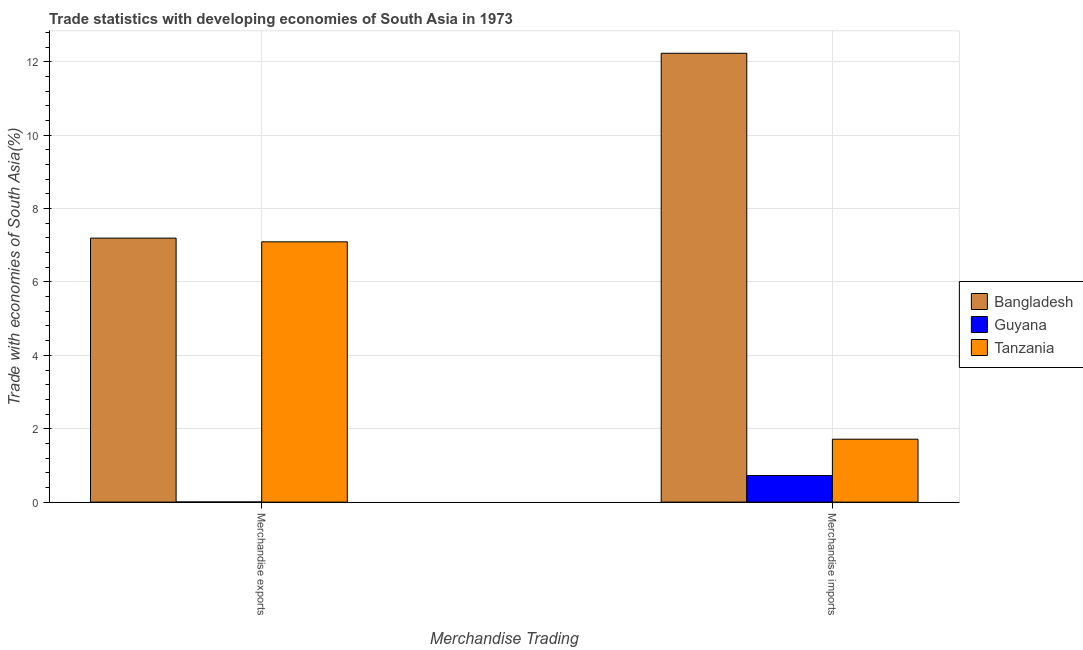How many different coloured bars are there?
Provide a short and direct response. 3. Are the number of bars on each tick of the X-axis equal?
Your answer should be compact. Yes. How many bars are there on the 2nd tick from the left?
Your response must be concise. 3. How many bars are there on the 1st tick from the right?
Your response must be concise. 3. What is the label of the 1st group of bars from the left?
Your response must be concise. Merchandise exports. What is the merchandise exports in Bangladesh?
Provide a succinct answer. 7.19. Across all countries, what is the maximum merchandise imports?
Keep it short and to the point. 12.23. Across all countries, what is the minimum merchandise imports?
Provide a short and direct response. 0.72. In which country was the merchandise imports maximum?
Provide a succinct answer. Bangladesh. In which country was the merchandise imports minimum?
Keep it short and to the point. Guyana. What is the total merchandise imports in the graph?
Provide a short and direct response. 14.67. What is the difference between the merchandise exports in Guyana and that in Tanzania?
Your answer should be compact. -7.09. What is the difference between the merchandise exports in Bangladesh and the merchandise imports in Guyana?
Provide a short and direct response. 6.47. What is the average merchandise exports per country?
Provide a short and direct response. 4.76. What is the difference between the merchandise exports and merchandise imports in Bangladesh?
Your answer should be compact. -5.04. In how many countries, is the merchandise imports greater than 4.8 %?
Give a very brief answer. 1. What is the ratio of the merchandise exports in Tanzania to that in Guyana?
Give a very brief answer. 1628.43. What does the 2nd bar from the left in Merchandise imports represents?
Keep it short and to the point. Guyana. What does the 1st bar from the right in Merchandise exports represents?
Make the answer very short. Tanzania. How many bars are there?
Provide a succinct answer. 6. Are all the bars in the graph horizontal?
Give a very brief answer. No. Are the values on the major ticks of Y-axis written in scientific E-notation?
Offer a terse response. No. Where does the legend appear in the graph?
Provide a succinct answer. Center right. What is the title of the graph?
Provide a short and direct response. Trade statistics with developing economies of South Asia in 1973. Does "Moldova" appear as one of the legend labels in the graph?
Ensure brevity in your answer.  No. What is the label or title of the X-axis?
Keep it short and to the point. Merchandise Trading. What is the label or title of the Y-axis?
Provide a short and direct response. Trade with economies of South Asia(%). What is the Trade with economies of South Asia(%) in Bangladesh in Merchandise exports?
Make the answer very short. 7.19. What is the Trade with economies of South Asia(%) of Guyana in Merchandise exports?
Ensure brevity in your answer.  0. What is the Trade with economies of South Asia(%) of Tanzania in Merchandise exports?
Your answer should be compact. 7.09. What is the Trade with economies of South Asia(%) of Bangladesh in Merchandise imports?
Your answer should be very brief. 12.23. What is the Trade with economies of South Asia(%) in Guyana in Merchandise imports?
Your response must be concise. 0.72. What is the Trade with economies of South Asia(%) in Tanzania in Merchandise imports?
Your response must be concise. 1.72. Across all Merchandise Trading, what is the maximum Trade with economies of South Asia(%) in Bangladesh?
Provide a succinct answer. 12.23. Across all Merchandise Trading, what is the maximum Trade with economies of South Asia(%) in Guyana?
Your answer should be compact. 0.72. Across all Merchandise Trading, what is the maximum Trade with economies of South Asia(%) of Tanzania?
Offer a terse response. 7.09. Across all Merchandise Trading, what is the minimum Trade with economies of South Asia(%) of Bangladesh?
Offer a terse response. 7.19. Across all Merchandise Trading, what is the minimum Trade with economies of South Asia(%) of Guyana?
Make the answer very short. 0. Across all Merchandise Trading, what is the minimum Trade with economies of South Asia(%) in Tanzania?
Your answer should be very brief. 1.72. What is the total Trade with economies of South Asia(%) in Bangladesh in the graph?
Offer a terse response. 19.43. What is the total Trade with economies of South Asia(%) of Guyana in the graph?
Offer a terse response. 0.73. What is the total Trade with economies of South Asia(%) of Tanzania in the graph?
Provide a short and direct response. 8.81. What is the difference between the Trade with economies of South Asia(%) in Bangladesh in Merchandise exports and that in Merchandise imports?
Make the answer very short. -5.04. What is the difference between the Trade with economies of South Asia(%) in Guyana in Merchandise exports and that in Merchandise imports?
Your response must be concise. -0.72. What is the difference between the Trade with economies of South Asia(%) in Tanzania in Merchandise exports and that in Merchandise imports?
Provide a short and direct response. 5.38. What is the difference between the Trade with economies of South Asia(%) of Bangladesh in Merchandise exports and the Trade with economies of South Asia(%) of Guyana in Merchandise imports?
Keep it short and to the point. 6.47. What is the difference between the Trade with economies of South Asia(%) in Bangladesh in Merchandise exports and the Trade with economies of South Asia(%) in Tanzania in Merchandise imports?
Your answer should be very brief. 5.48. What is the difference between the Trade with economies of South Asia(%) of Guyana in Merchandise exports and the Trade with economies of South Asia(%) of Tanzania in Merchandise imports?
Provide a succinct answer. -1.71. What is the average Trade with economies of South Asia(%) of Bangladesh per Merchandise Trading?
Offer a very short reply. 9.71. What is the average Trade with economies of South Asia(%) of Guyana per Merchandise Trading?
Your answer should be compact. 0.36. What is the average Trade with economies of South Asia(%) in Tanzania per Merchandise Trading?
Offer a very short reply. 4.4. What is the difference between the Trade with economies of South Asia(%) of Bangladesh and Trade with economies of South Asia(%) of Guyana in Merchandise exports?
Ensure brevity in your answer.  7.19. What is the difference between the Trade with economies of South Asia(%) of Bangladesh and Trade with economies of South Asia(%) of Tanzania in Merchandise exports?
Offer a terse response. 0.1. What is the difference between the Trade with economies of South Asia(%) of Guyana and Trade with economies of South Asia(%) of Tanzania in Merchandise exports?
Offer a very short reply. -7.09. What is the difference between the Trade with economies of South Asia(%) in Bangladesh and Trade with economies of South Asia(%) in Guyana in Merchandise imports?
Your response must be concise. 11.51. What is the difference between the Trade with economies of South Asia(%) of Bangladesh and Trade with economies of South Asia(%) of Tanzania in Merchandise imports?
Ensure brevity in your answer.  10.52. What is the difference between the Trade with economies of South Asia(%) in Guyana and Trade with economies of South Asia(%) in Tanzania in Merchandise imports?
Offer a very short reply. -0.99. What is the ratio of the Trade with economies of South Asia(%) in Bangladesh in Merchandise exports to that in Merchandise imports?
Provide a succinct answer. 0.59. What is the ratio of the Trade with economies of South Asia(%) in Guyana in Merchandise exports to that in Merchandise imports?
Offer a terse response. 0.01. What is the ratio of the Trade with economies of South Asia(%) in Tanzania in Merchandise exports to that in Merchandise imports?
Your answer should be very brief. 4.14. What is the difference between the highest and the second highest Trade with economies of South Asia(%) of Bangladesh?
Your response must be concise. 5.04. What is the difference between the highest and the second highest Trade with economies of South Asia(%) in Guyana?
Your answer should be very brief. 0.72. What is the difference between the highest and the second highest Trade with economies of South Asia(%) in Tanzania?
Offer a terse response. 5.38. What is the difference between the highest and the lowest Trade with economies of South Asia(%) in Bangladesh?
Your answer should be compact. 5.04. What is the difference between the highest and the lowest Trade with economies of South Asia(%) of Guyana?
Ensure brevity in your answer.  0.72. What is the difference between the highest and the lowest Trade with economies of South Asia(%) in Tanzania?
Your answer should be very brief. 5.38. 